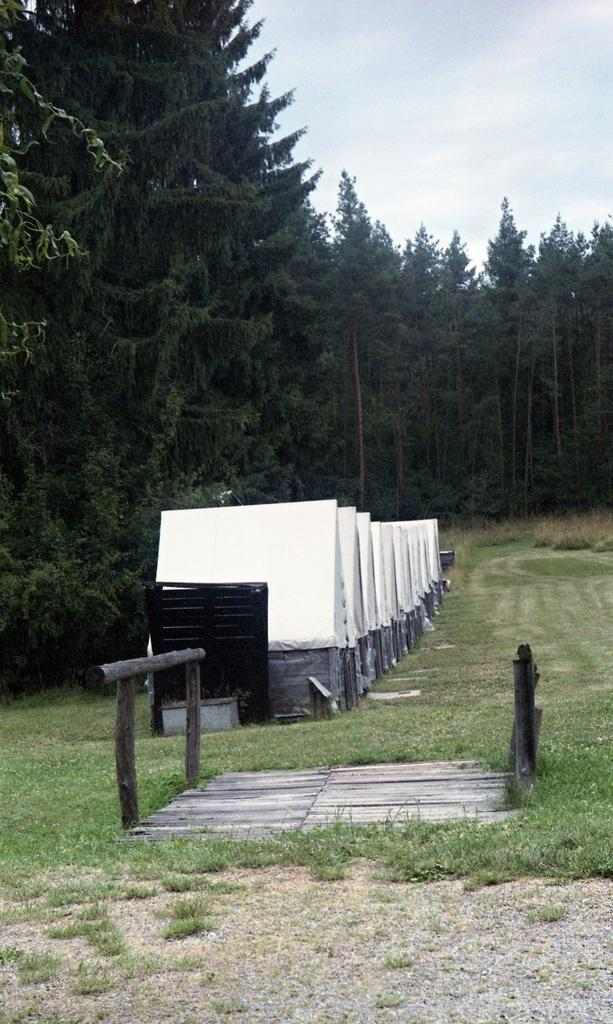What type of structures can be seen in the image? There are sheds in the image. What type of vegetation is present in the image? There are trees in the image. What type of material is visible in the image? There are logs in the image. What object can be seen in the image that might be used for writing or displaying information? There is a board in the image. What part of the natural environment is visible in the image? The sky is visible at the top of the image, and the ground is visible at the bottom of the image. What type of pets are visible in the image? There are no pets visible in the image. What day of the week is depicted in the image? The image does not depict a specific day of the week; it is a still image of sheds, trees, logs, a board, and the sky and ground. 